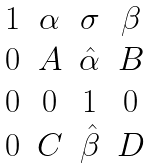Convert formula to latex. <formula><loc_0><loc_0><loc_500><loc_500>\begin{matrix} 1 & \alpha & \sigma & \beta \\ 0 & A & \hat { \alpha } & B \\ 0 & 0 & 1 & 0 \\ 0 & C & \hat { \beta } & D \end{matrix}</formula> 